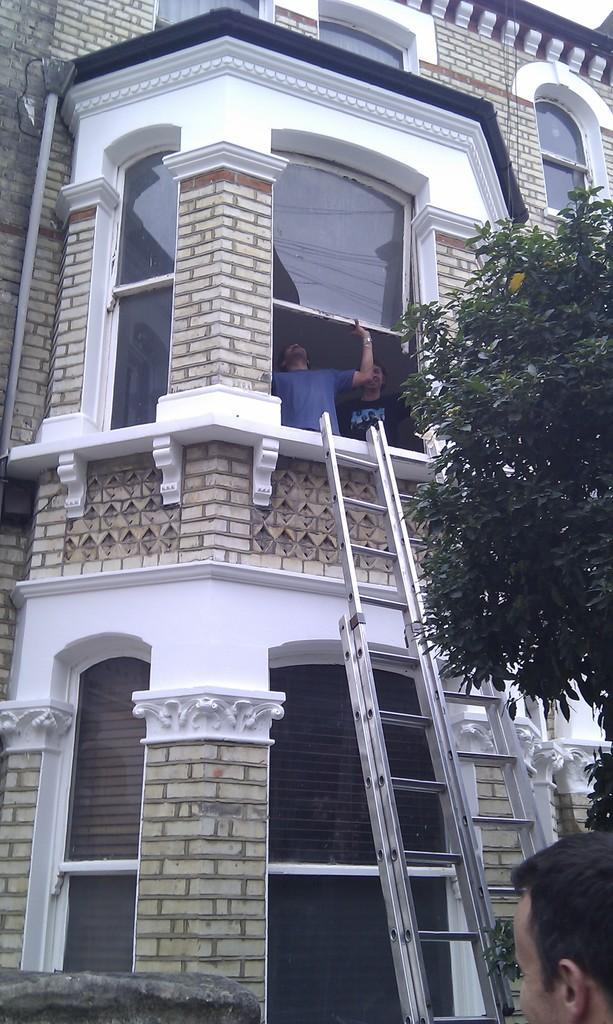Describe this image in one or two sentences. In this picture there is a building which has a staircase in front of it and there is a person holding a glass window and there is another person beside him and there is a person and a tree in the right corner. 